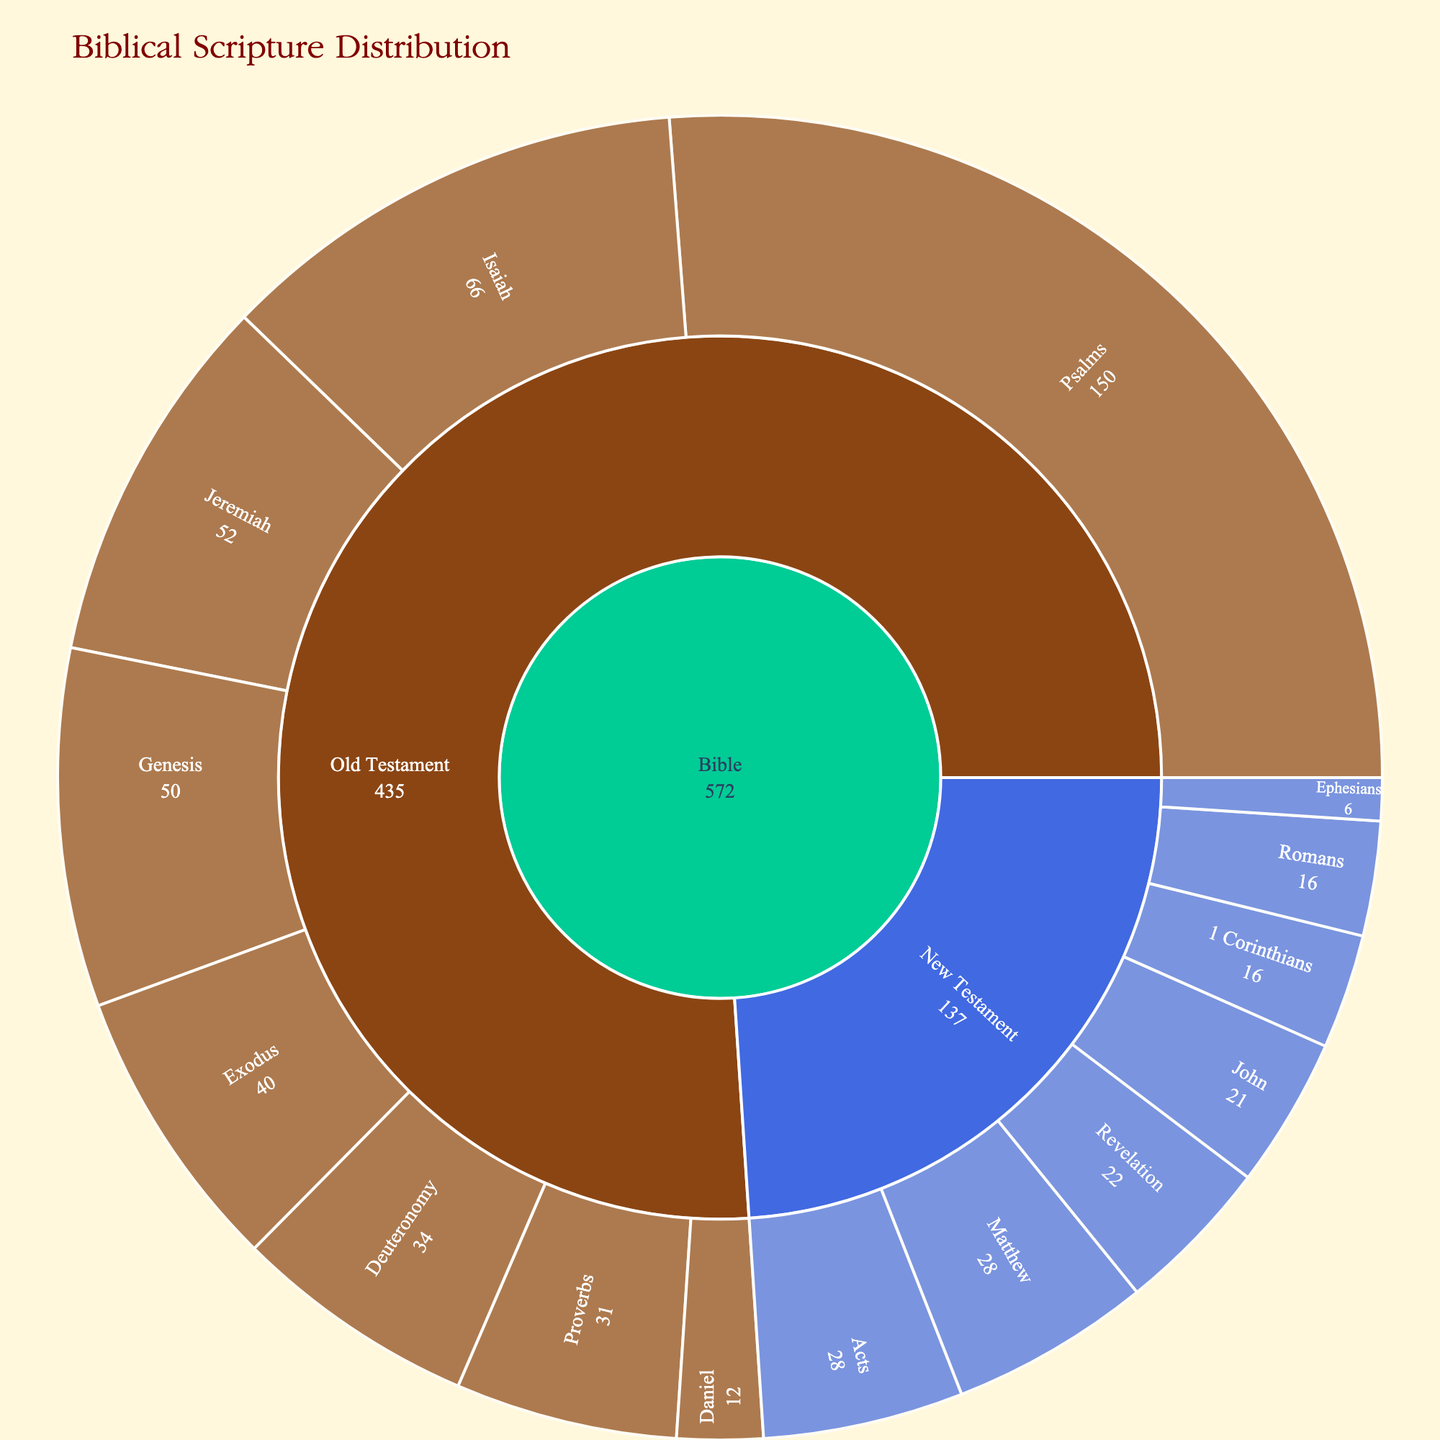What is the title of the sunburst plot? The title of the plot is located at the top and is displayed prominently, usually in a larger font.
Answer: Biblical Scripture Distribution What colors are used to represent the Old Testament and the New Testament? The colors can be identified by looking at the sections of the sunburst plot and referring to the color legend or directly observing the shaded areas.
Answer: SaddleBrown and RoyalBlue How many chapters are in the Book of Psalms? The number of chapters can be found directly by looking at the section labeled "Psalms" within the "Old Testament" branch of the plot.
Answer: 150 Which book has more chapters, Genesis or Exodus? Compare the labeled sections of "Genesis" and "Exodus" within the "Old Testament" branch and note their chapter counts.
Answer: Genesis How many total chapters are in the New Testament books shown in the plot? Sum the chapter counts for all New Testament books: Matthew (28), John (21), Romans (16), Revelation (22), Acts (28), 1 Corinthians (16), and Ephesians (6). Calculated as 28 + 21 + 16 + 22 + 28 + 16 + 6.
Answer: 137 What is the least number of chapters in any of the books listed, and which book(s) does it belong to? Scan through the chapter counts and identify the smallest number; find the corresponding book(s).
Answer: 6, Ephesians If you combine the books of Isaiah and Daniel, how many chapters do they have together? Add the chapters of Isaiah (66) and Daniel (12). Calculation: 66 + 12.
Answer: 78 Which Testament has more total chapters, and by how many? Sum the chapters of all books in the Old Testament and New Testament separately, then find the difference.
Old Testament: Genesis (50), Exodus (40), Psalms (150), Isaiah (66), Daniel (12), Proverbs (31), Jeremiah (52), Deuteronomy (34). Total = 50 + 40 + 150 + 66 + 12 + 31 + 52 + 34 = 435.
New Testament: Matthew (28), John (21), Romans (16), Revelation (22), Acts (28), 1 Corinthians (16), Ephesians (6). Total = 28 + 21 + 16 + 22 + 28 + 16 + 6 = 137.
Difference: 435 - 137.
Answer: Old Testament, 298 Which book has more chapters, Jeremiah or Deuteronomy? Compare the labeled sections of "Jeremiah" and "Deuteronomy" within the "Old Testament" branch and note their chapter counts.
Answer: Jeremiah How many total books are represented in the New Testament branch of the sunburst plot? Count the labeled sections within the "New Testament" branch.
Answer: 7 